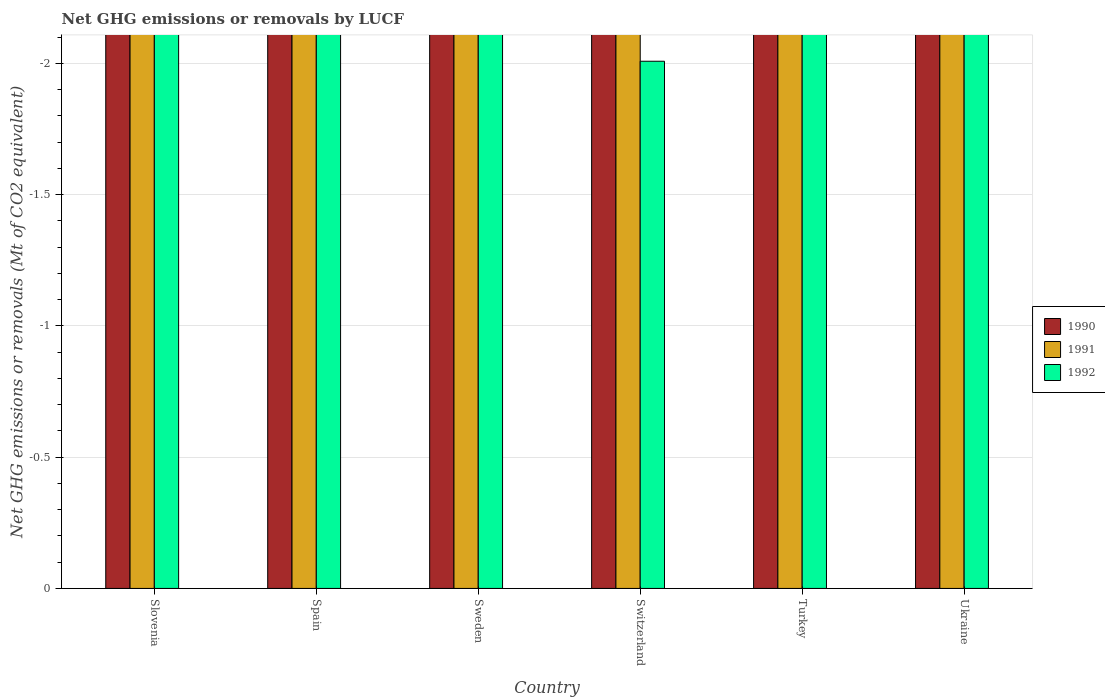How many different coloured bars are there?
Give a very brief answer. 0. Are the number of bars per tick equal to the number of legend labels?
Your answer should be very brief. No. Are the number of bars on each tick of the X-axis equal?
Provide a succinct answer. Yes. How many bars are there on the 6th tick from the right?
Provide a succinct answer. 0. In how many cases, is the number of bars for a given country not equal to the number of legend labels?
Provide a succinct answer. 6. What is the total net GHG emissions or removals by LUCF in 1992 in the graph?
Provide a succinct answer. 0. What is the difference between the net GHG emissions or removals by LUCF in 1990 in Sweden and the net GHG emissions or removals by LUCF in 1991 in Ukraine?
Your response must be concise. 0. Is it the case that in every country, the sum of the net GHG emissions or removals by LUCF in 1992 and net GHG emissions or removals by LUCF in 1991 is greater than the net GHG emissions or removals by LUCF in 1990?
Ensure brevity in your answer.  No. Are the values on the major ticks of Y-axis written in scientific E-notation?
Give a very brief answer. No. Where does the legend appear in the graph?
Give a very brief answer. Center right. How are the legend labels stacked?
Your answer should be very brief. Vertical. What is the title of the graph?
Offer a terse response. Net GHG emissions or removals by LUCF. What is the label or title of the Y-axis?
Provide a succinct answer. Net GHG emissions or removals (Mt of CO2 equivalent). What is the Net GHG emissions or removals (Mt of CO2 equivalent) in 1991 in Slovenia?
Your answer should be very brief. 0. What is the Net GHG emissions or removals (Mt of CO2 equivalent) of 1991 in Spain?
Your response must be concise. 0. What is the Net GHG emissions or removals (Mt of CO2 equivalent) of 1991 in Sweden?
Your answer should be very brief. 0. What is the Net GHG emissions or removals (Mt of CO2 equivalent) in 1991 in Switzerland?
Your answer should be very brief. 0. What is the Net GHG emissions or removals (Mt of CO2 equivalent) of 1992 in Switzerland?
Offer a terse response. 0. What is the Net GHG emissions or removals (Mt of CO2 equivalent) in 1990 in Turkey?
Provide a succinct answer. 0. What is the Net GHG emissions or removals (Mt of CO2 equivalent) in 1991 in Turkey?
Your answer should be compact. 0. What is the Net GHG emissions or removals (Mt of CO2 equivalent) in 1992 in Turkey?
Offer a terse response. 0. What is the Net GHG emissions or removals (Mt of CO2 equivalent) of 1990 in Ukraine?
Give a very brief answer. 0. What is the total Net GHG emissions or removals (Mt of CO2 equivalent) of 1991 in the graph?
Give a very brief answer. 0. What is the total Net GHG emissions or removals (Mt of CO2 equivalent) in 1992 in the graph?
Your answer should be compact. 0. What is the average Net GHG emissions or removals (Mt of CO2 equivalent) of 1990 per country?
Your answer should be compact. 0. 